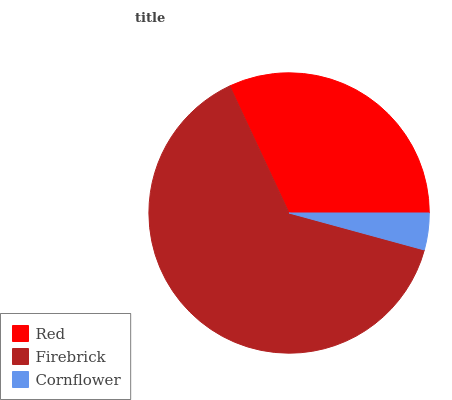Is Cornflower the minimum?
Answer yes or no. Yes. Is Firebrick the maximum?
Answer yes or no. Yes. Is Firebrick the minimum?
Answer yes or no. No. Is Cornflower the maximum?
Answer yes or no. No. Is Firebrick greater than Cornflower?
Answer yes or no. Yes. Is Cornflower less than Firebrick?
Answer yes or no. Yes. Is Cornflower greater than Firebrick?
Answer yes or no. No. Is Firebrick less than Cornflower?
Answer yes or no. No. Is Red the high median?
Answer yes or no. Yes. Is Red the low median?
Answer yes or no. Yes. Is Cornflower the high median?
Answer yes or no. No. Is Cornflower the low median?
Answer yes or no. No. 